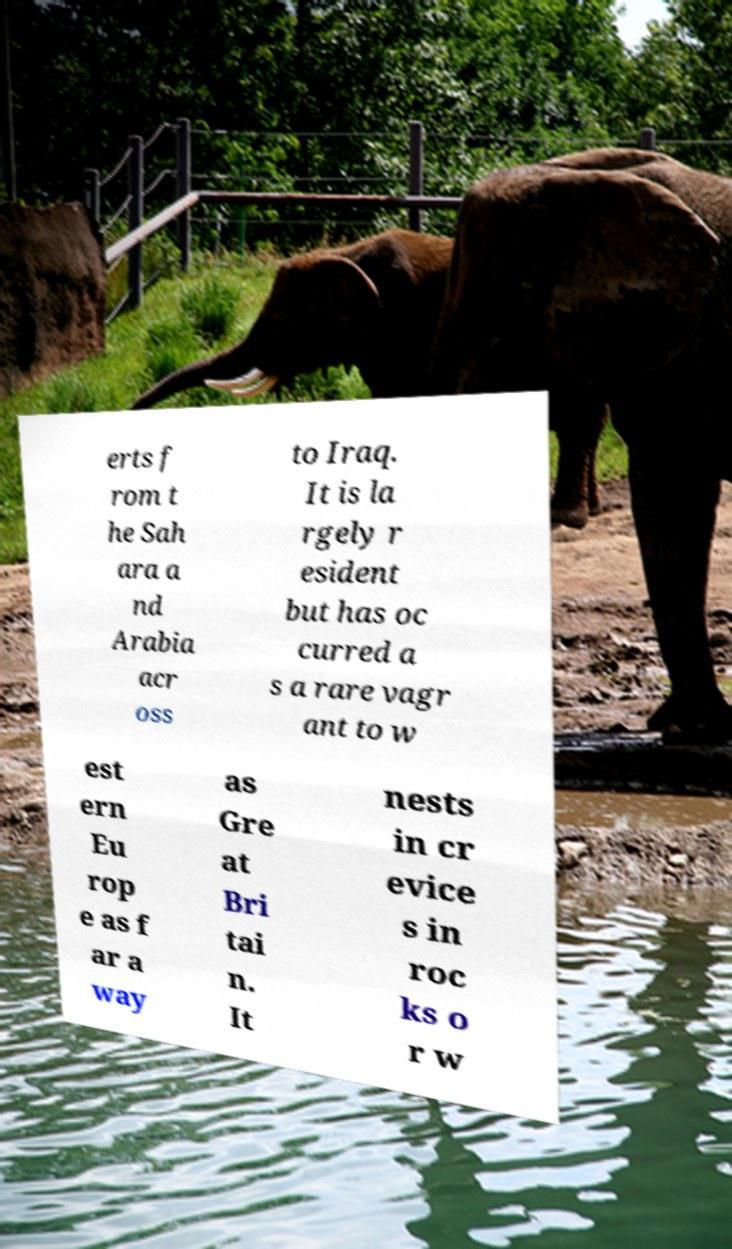I need the written content from this picture converted into text. Can you do that? erts f rom t he Sah ara a nd Arabia acr oss to Iraq. It is la rgely r esident but has oc curred a s a rare vagr ant to w est ern Eu rop e as f ar a way as Gre at Bri tai n. It nests in cr evice s in roc ks o r w 